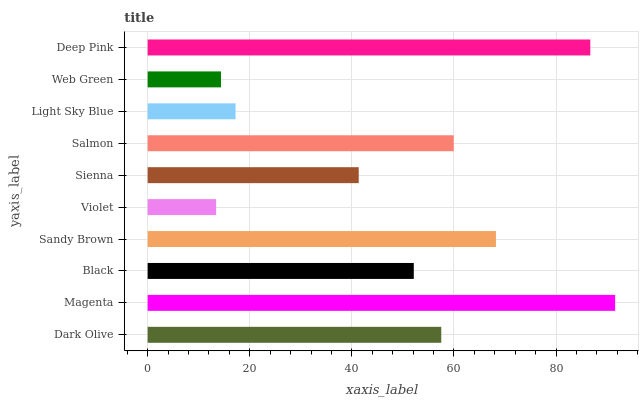Is Violet the minimum?
Answer yes or no. Yes. Is Magenta the maximum?
Answer yes or no. Yes. Is Black the minimum?
Answer yes or no. No. Is Black the maximum?
Answer yes or no. No. Is Magenta greater than Black?
Answer yes or no. Yes. Is Black less than Magenta?
Answer yes or no. Yes. Is Black greater than Magenta?
Answer yes or no. No. Is Magenta less than Black?
Answer yes or no. No. Is Dark Olive the high median?
Answer yes or no. Yes. Is Black the low median?
Answer yes or no. Yes. Is Sienna the high median?
Answer yes or no. No. Is Violet the low median?
Answer yes or no. No. 